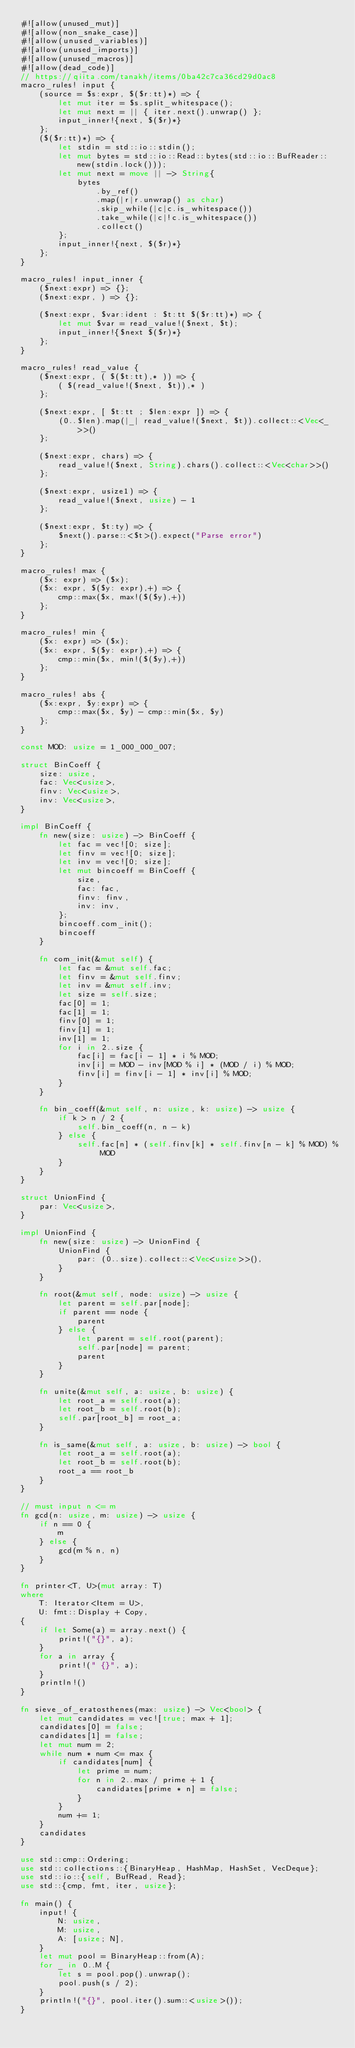<code> <loc_0><loc_0><loc_500><loc_500><_Rust_>#![allow(unused_mut)]
#![allow(non_snake_case)]
#![allow(unused_variables)]
#![allow(unused_imports)]
#![allow(unused_macros)]
#![allow(dead_code)]
// https://qiita.com/tanakh/items/0ba42c7ca36cd29d0ac8
macro_rules! input {
    (source = $s:expr, $($r:tt)*) => {
        let mut iter = $s.split_whitespace();
        let mut next = || { iter.next().unwrap() };
        input_inner!{next, $($r)*}
    };
    ($($r:tt)*) => {
        let stdin = std::io::stdin();
        let mut bytes = std::io::Read::bytes(std::io::BufReader::new(stdin.lock()));
        let mut next = move || -> String{
            bytes
                .by_ref()
                .map(|r|r.unwrap() as char)
                .skip_while(|c|c.is_whitespace())
                .take_while(|c|!c.is_whitespace())
                .collect()
        };
        input_inner!{next, $($r)*}
    };
}

macro_rules! input_inner {
    ($next:expr) => {};
    ($next:expr, ) => {};

    ($next:expr, $var:ident : $t:tt $($r:tt)*) => {
        let mut $var = read_value!($next, $t);
        input_inner!{$next $($r)*}
    };
}

macro_rules! read_value {
    ($next:expr, ( $($t:tt),* )) => {
        ( $(read_value!($next, $t)),* )
    };

    ($next:expr, [ $t:tt ; $len:expr ]) => {
        (0..$len).map(|_| read_value!($next, $t)).collect::<Vec<_>>()
    };

    ($next:expr, chars) => {
        read_value!($next, String).chars().collect::<Vec<char>>()
    };

    ($next:expr, usize1) => {
        read_value!($next, usize) - 1
    };

    ($next:expr, $t:ty) => {
        $next().parse::<$t>().expect("Parse error")
    };
}

macro_rules! max {
    ($x: expr) => ($x);
    ($x: expr, $($y: expr),+) => {
        cmp::max($x, max!($($y),+))
    };
}

macro_rules! min {
    ($x: expr) => ($x);
    ($x: expr, $($y: expr),+) => {
        cmp::min($x, min!($($y),+))
    };
}

macro_rules! abs {
    ($x:expr, $y:expr) => {
        cmp::max($x, $y) - cmp::min($x, $y)
    };
}

const MOD: usize = 1_000_000_007;

struct BinCoeff {
    size: usize,
    fac: Vec<usize>,
    finv: Vec<usize>,
    inv: Vec<usize>,
}

impl BinCoeff {
    fn new(size: usize) -> BinCoeff {
        let fac = vec![0; size];
        let finv = vec![0; size];
        let inv = vec![0; size];
        let mut bincoeff = BinCoeff {
            size,
            fac: fac,
            finv: finv,
            inv: inv,
        };
        bincoeff.com_init();
        bincoeff
    }

    fn com_init(&mut self) {
        let fac = &mut self.fac;
        let finv = &mut self.finv;
        let inv = &mut self.inv;
        let size = self.size;
        fac[0] = 1;
        fac[1] = 1;
        finv[0] = 1;
        finv[1] = 1;
        inv[1] = 1;
        for i in 2..size {
            fac[i] = fac[i - 1] * i % MOD;
            inv[i] = MOD - inv[MOD % i] * (MOD / i) % MOD;
            finv[i] = finv[i - 1] * inv[i] % MOD;
        }
    }

    fn bin_coeff(&mut self, n: usize, k: usize) -> usize {
        if k > n / 2 {
            self.bin_coeff(n, n - k)
        } else {
            self.fac[n] * (self.finv[k] * self.finv[n - k] % MOD) % MOD
        }
    }
}

struct UnionFind {
    par: Vec<usize>,
}

impl UnionFind {
    fn new(size: usize) -> UnionFind {
        UnionFind {
            par: (0..size).collect::<Vec<usize>>(),
        }
    }

    fn root(&mut self, node: usize) -> usize {
        let parent = self.par[node];
        if parent == node {
            parent
        } else {
            let parent = self.root(parent);
            self.par[node] = parent;
            parent
        }
    }

    fn unite(&mut self, a: usize, b: usize) {
        let root_a = self.root(a);
        let root_b = self.root(b);
        self.par[root_b] = root_a;
    }

    fn is_same(&mut self, a: usize, b: usize) -> bool {
        let root_a = self.root(a);
        let root_b = self.root(b);
        root_a == root_b
    }
}

// must input n <= m
fn gcd(n: usize, m: usize) -> usize {
    if n == 0 {
        m
    } else {
        gcd(m % n, n)
    }
}

fn printer<T, U>(mut array: T)
where
    T: Iterator<Item = U>,
    U: fmt::Display + Copy,
{
    if let Some(a) = array.next() {
        print!("{}", a);
    }
    for a in array {
        print!(" {}", a);
    }
    println!()
}

fn sieve_of_eratosthenes(max: usize) -> Vec<bool> {
    let mut candidates = vec![true; max + 1];
    candidates[0] = false;
    candidates[1] = false;
    let mut num = 2;
    while num * num <= max {
        if candidates[num] {
            let prime = num;
            for n in 2..max / prime + 1 {
                candidates[prime * n] = false;
            }
        }
        num += 1;
    }
    candidates
}

use std::cmp::Ordering;
use std::collections::{BinaryHeap, HashMap, HashSet, VecDeque};
use std::io::{self, BufRead, Read};
use std::{cmp, fmt, iter, usize};

fn main() {
    input! {
        N: usize,
        M: usize,
        A: [usize; N],
    }
    let mut pool = BinaryHeap::from(A);
    for _ in 0..M {
        let s = pool.pop().unwrap();
        pool.push(s / 2);
    }
    println!("{}", pool.iter().sum::<usize>());
}
</code> 